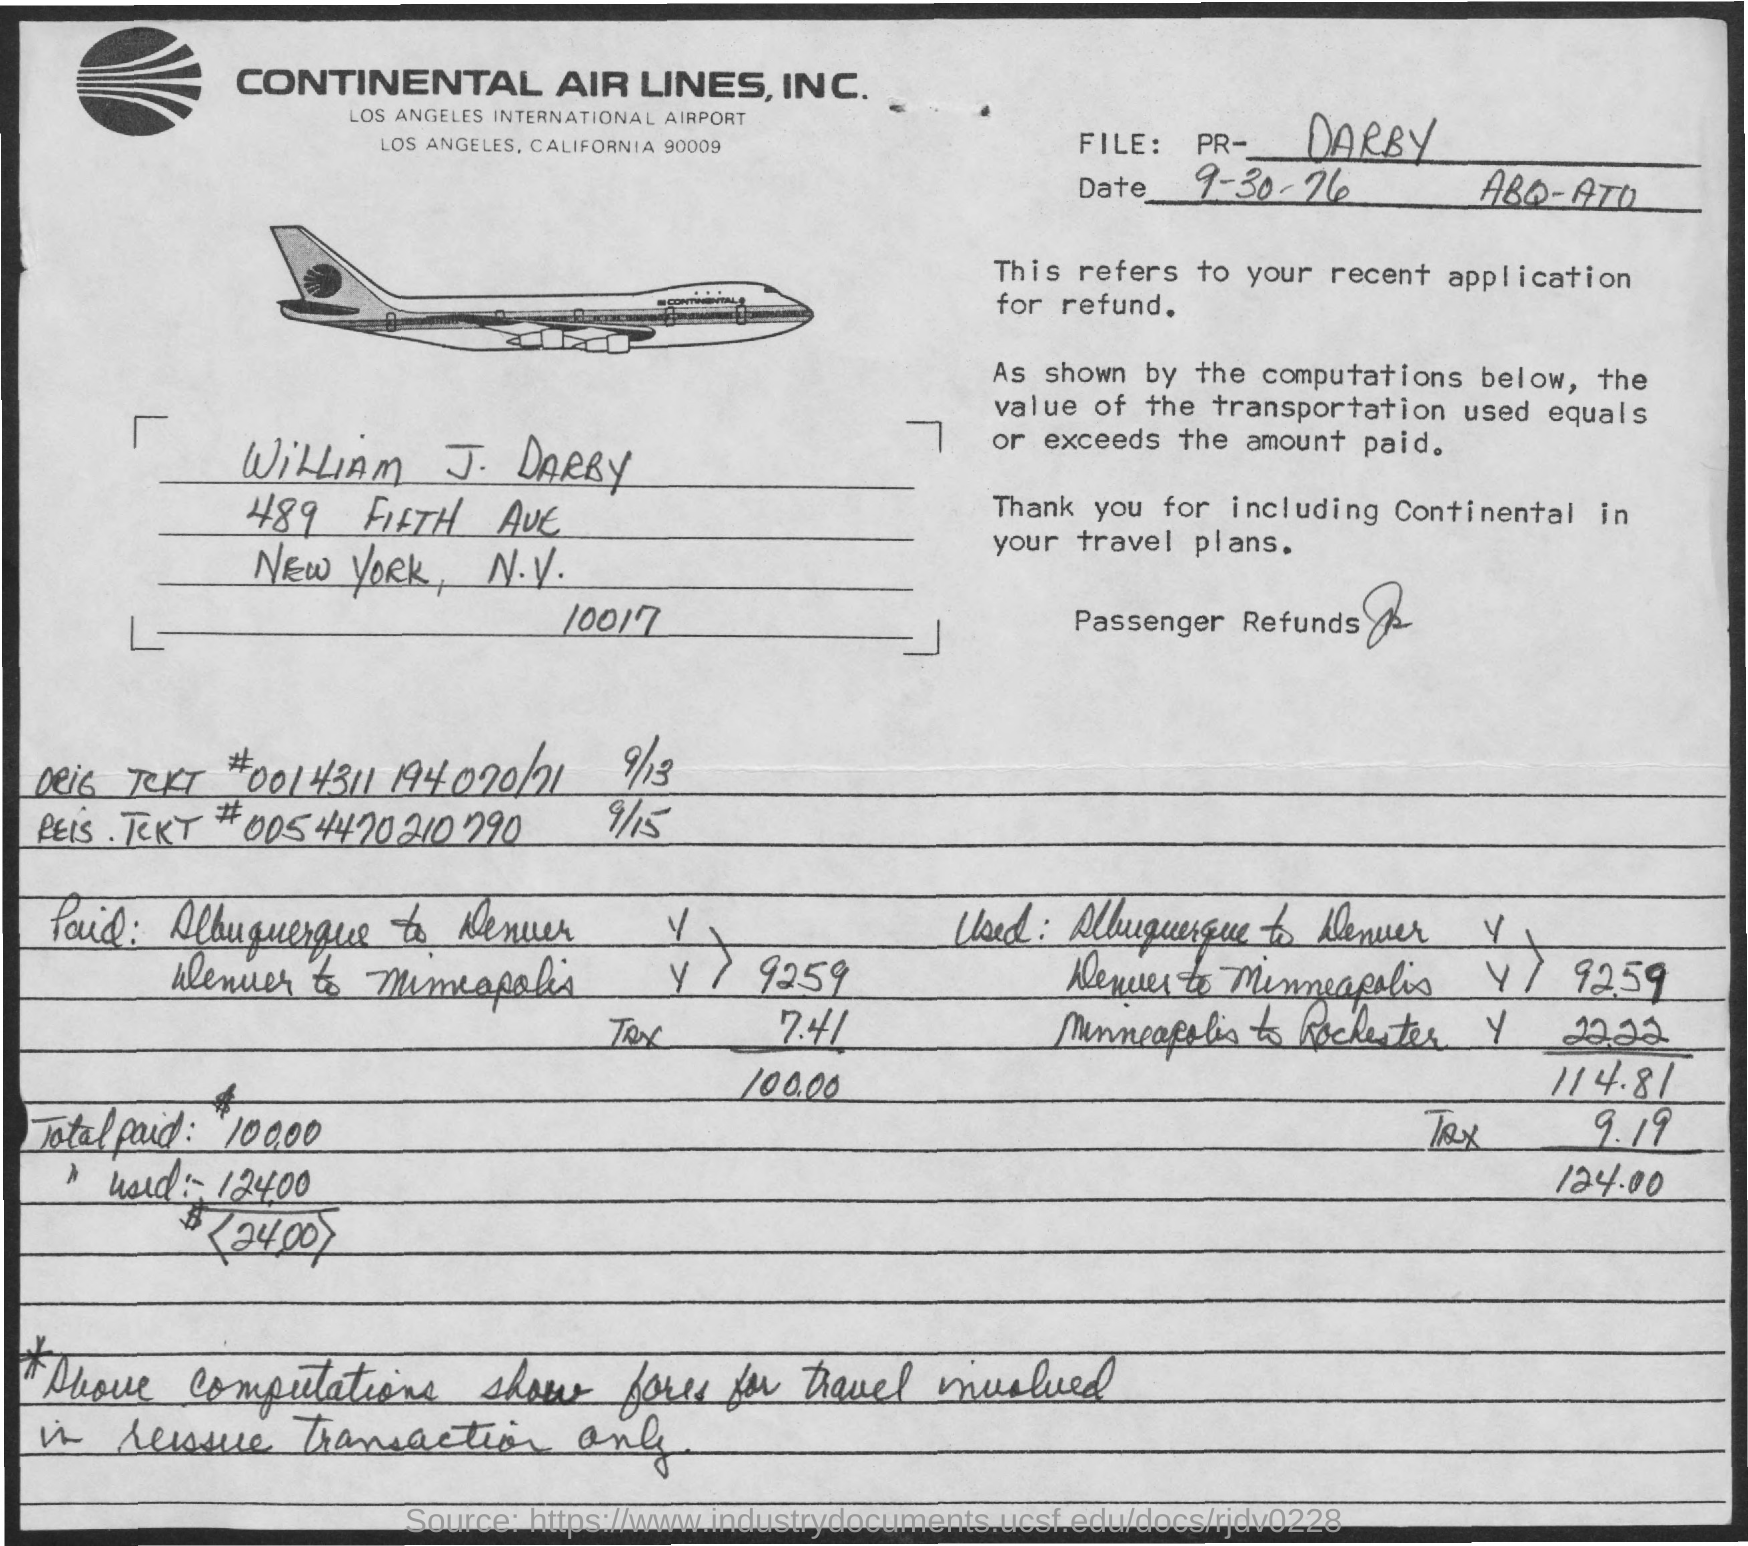Highlight a few significant elements in this photo. The document mentions the date of September 30, 1976. The total amount paid is 100.00. The name of the person is Darby. 